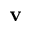<formula> <loc_0><loc_0><loc_500><loc_500>v</formula> 